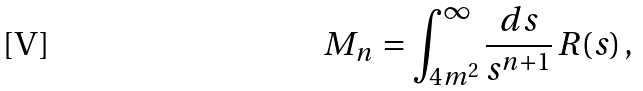<formula> <loc_0><loc_0><loc_500><loc_500>M _ { n } \, = \int _ { 4 m ^ { 2 } } ^ { \infty } \frac { d s } { s ^ { n + 1 } } \, R ( s ) \, ,</formula> 